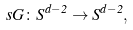Convert formula to latex. <formula><loc_0><loc_0><loc_500><loc_500>\ s G \colon S ^ { d - 2 } \rightarrow S ^ { d - 2 } ,</formula> 